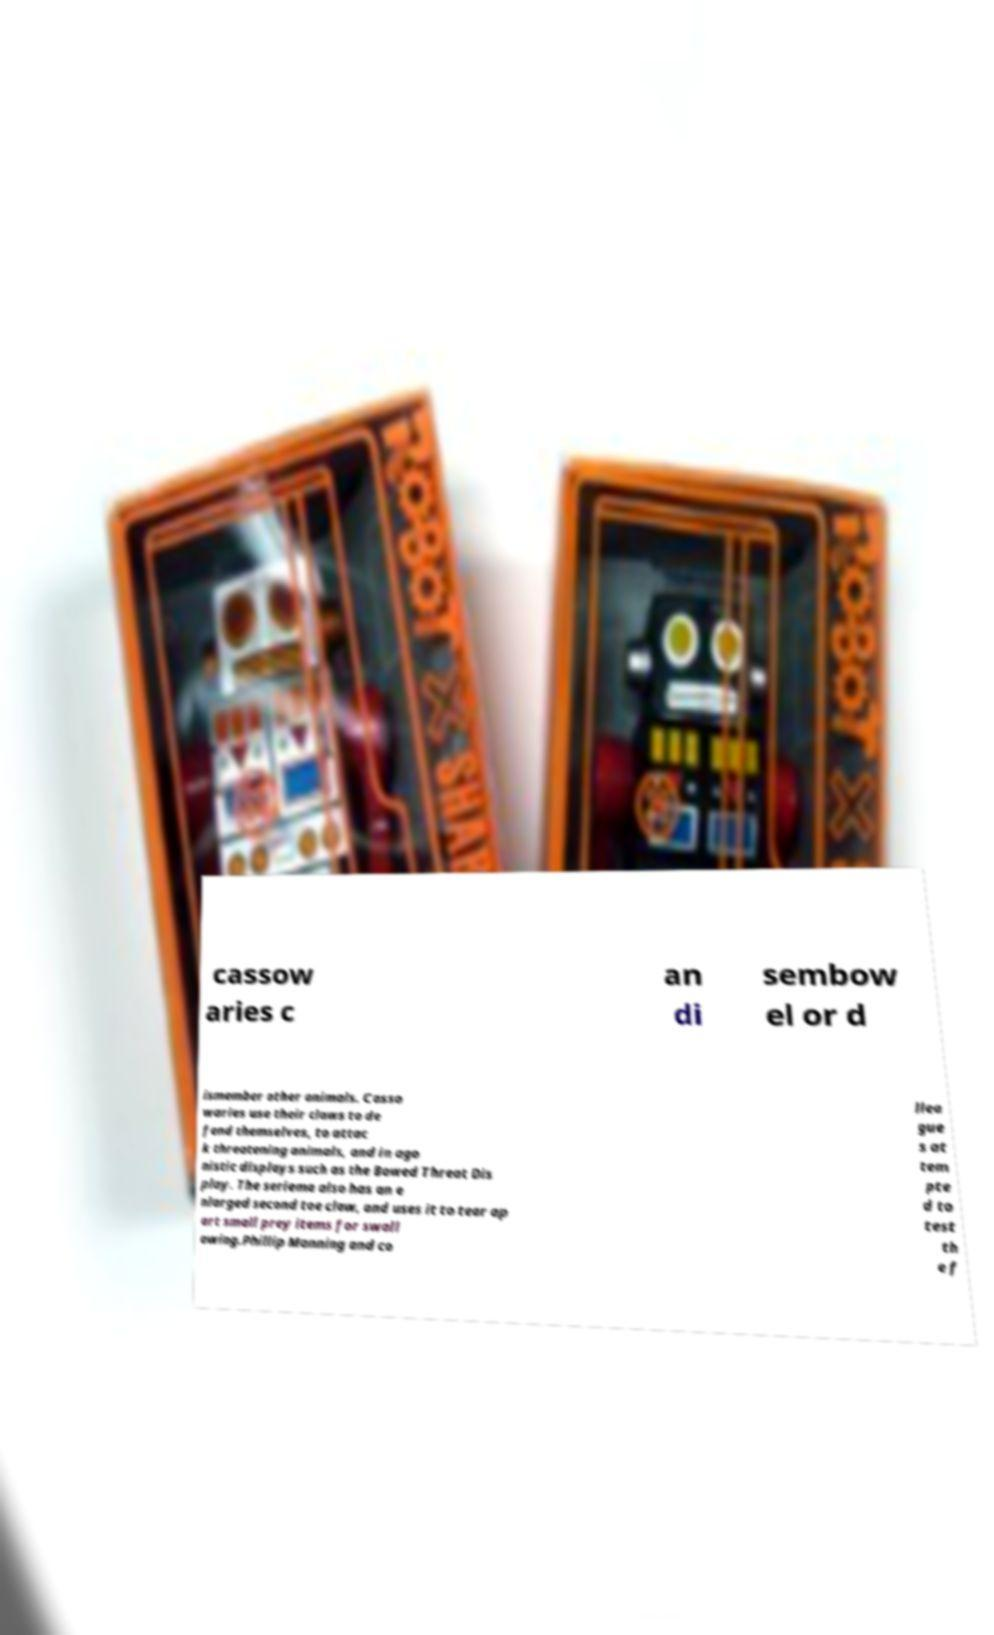Can you read and provide the text displayed in the image?This photo seems to have some interesting text. Can you extract and type it out for me? cassow aries c an di sembow el or d ismember other animals. Casso waries use their claws to de fend themselves, to attac k threatening animals, and in ago nistic displays such as the Bowed Threat Dis play. The seriema also has an e nlarged second toe claw, and uses it to tear ap art small prey items for swall owing.Phillip Manning and co llea gue s at tem pte d to test th e f 